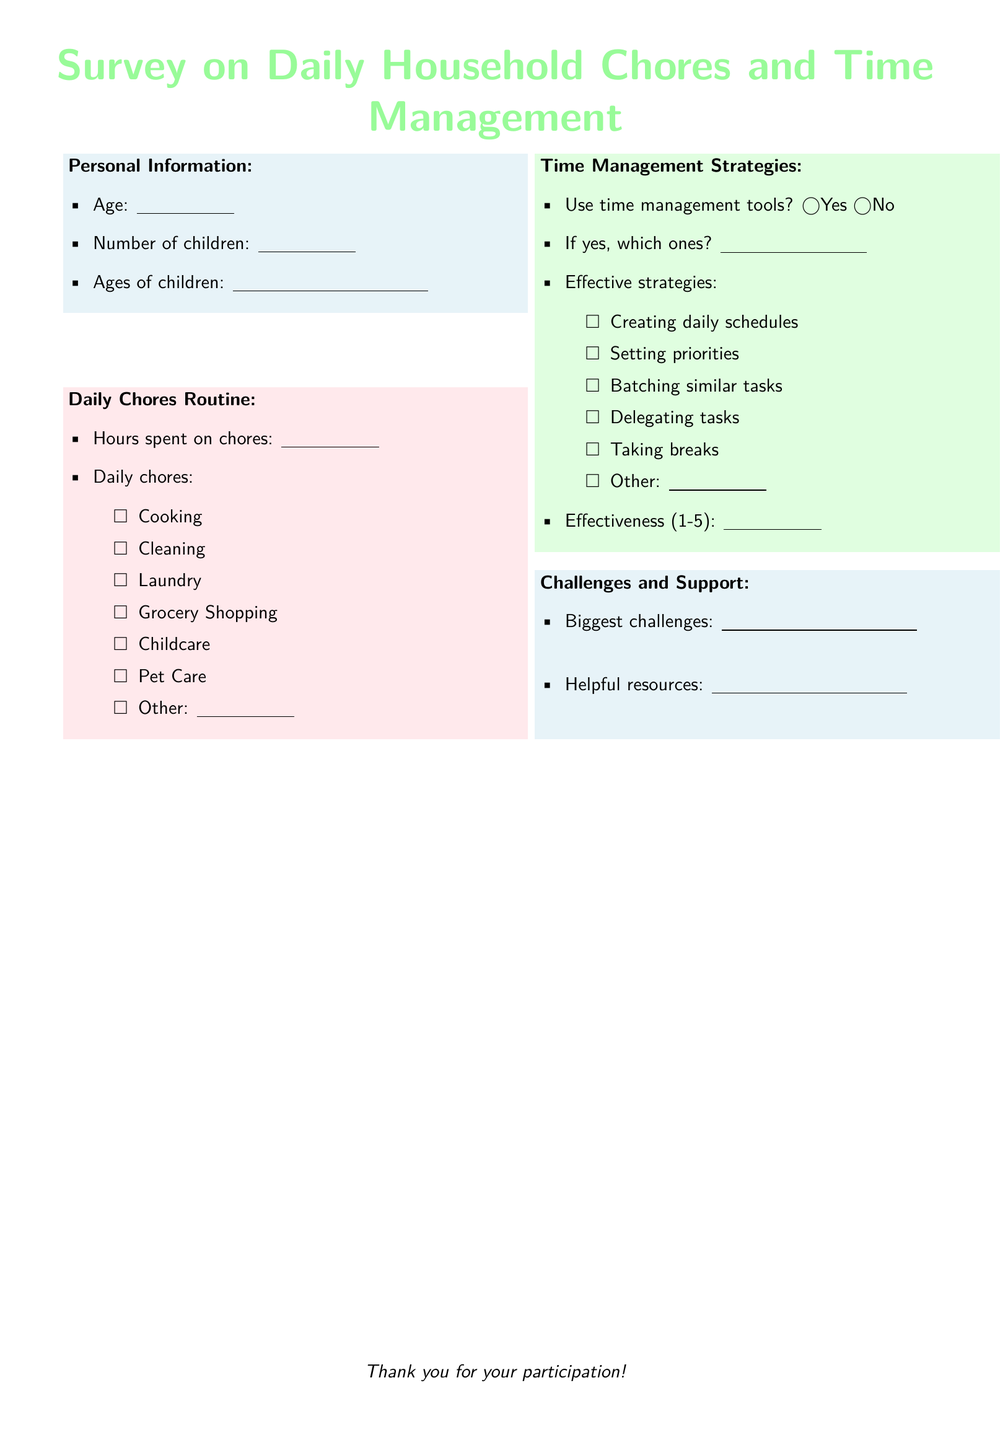What is the age of the respondent? The age of the respondent can be found in the personal information section of the document.
Answer: ______________ How many children does the respondent have? The number of children is indicated in the personal information section.
Answer: ______________ What is one of the daily chores listed in the document? Daily chores are listed in the section titled "Daily Chores Routine."
Answer: Cooking What are two time management strategies mentioned? Time management strategies are listed in the "Time Management Strategies" section.
Answer: Creating daily schedules, Setting priorities What is the maximum effectiveness rating according to the document? The effectiveness rating is indicated in the time management section where respondents rate from 1 to 5.
Answer: 5 What is an example of a challenge mentioned in the survey? The biggest challenges faced by respondents are indicated in the "Challenges and Support" section.
Answer: ______________ How much time does the respondent spend on chores? The hours spent on chores is captured under "Daily Chores Routine."
Answer: ______________ Does the document include a section for helpful resources? Yes or no is determined by the content under "Challenges and Support."
Answer: Yes What color is used for the header section of the survey? The color used for the header is stated at the beginning of the "Survey on Daily Household Chores and Time Management."
Answer: Pastel green 